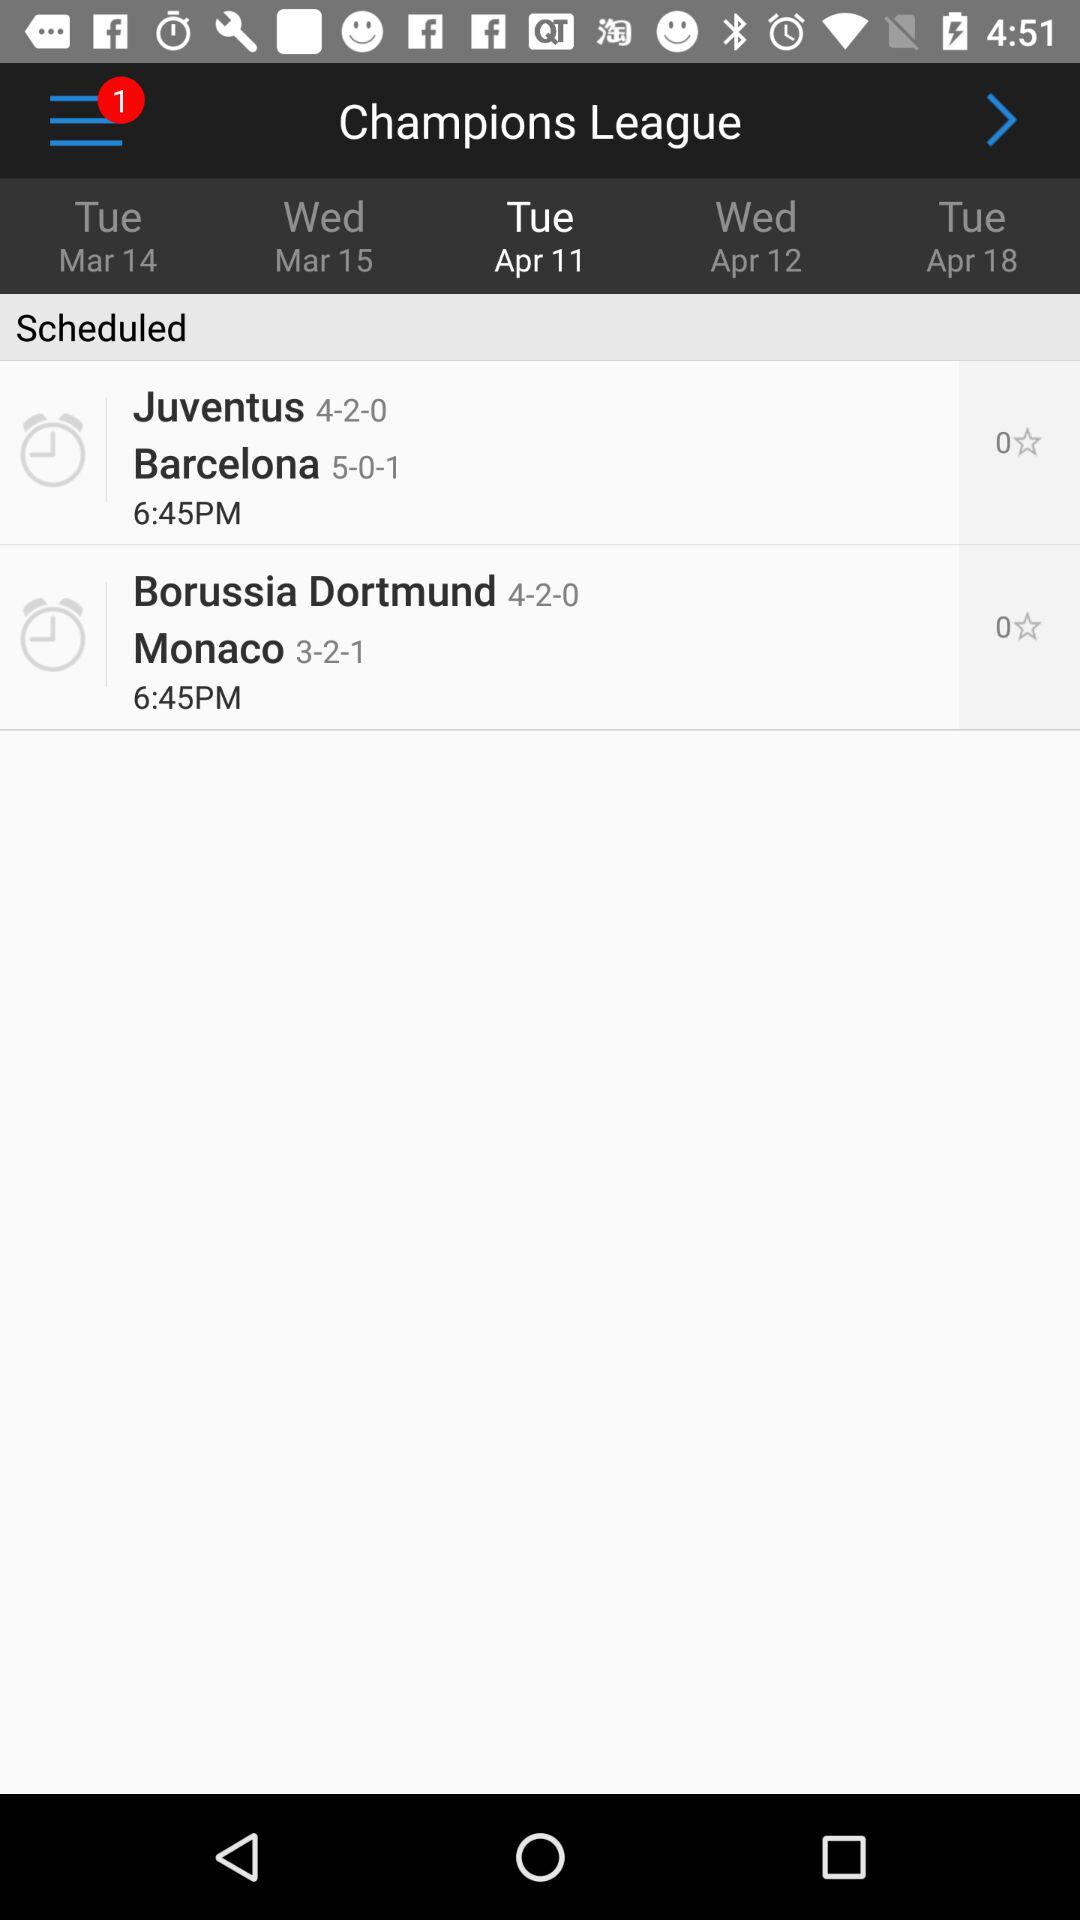What is the time of the Borussia Dortmund vs Monaco match? The time is 6:45 pm. 